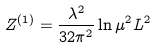Convert formula to latex. <formula><loc_0><loc_0><loc_500><loc_500>Z ^ { ( 1 ) } = \frac { \lambda ^ { 2 } } { 3 2 \pi ^ { 2 } } \ln \mu ^ { 2 } L ^ { 2 }</formula> 